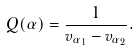Convert formula to latex. <formula><loc_0><loc_0><loc_500><loc_500>Q ( \alpha ) = \frac { 1 } { v _ { \alpha _ { 1 } } - v _ { \alpha _ { 2 } } } .</formula> 